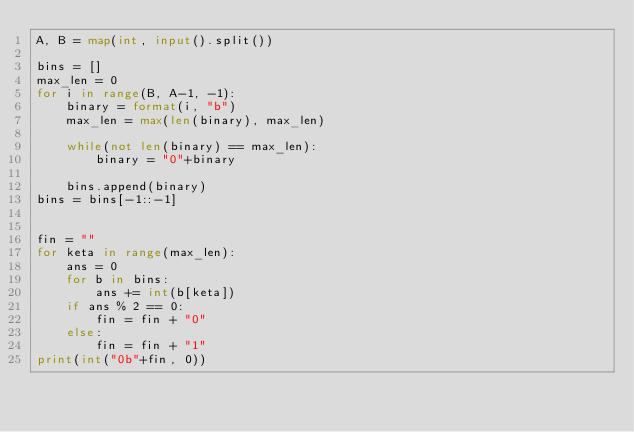Convert code to text. <code><loc_0><loc_0><loc_500><loc_500><_Python_>A, B = map(int, input().split())
           
bins = []
max_len = 0
for i in range(B, A-1, -1):
    binary = format(i, "b")
    max_len = max(len(binary), max_len)

    while(not len(binary) == max_len):
        binary = "0"+binary
    
    bins.append(binary)
bins = bins[-1::-1]
           

fin = ""
for keta in range(max_len):
    ans = 0
    for b in bins:
        ans += int(b[keta])
    if ans % 2 == 0:
        fin = fin + "0"
    else:
        fin = fin + "1"
print(int("0b"+fin, 0))</code> 